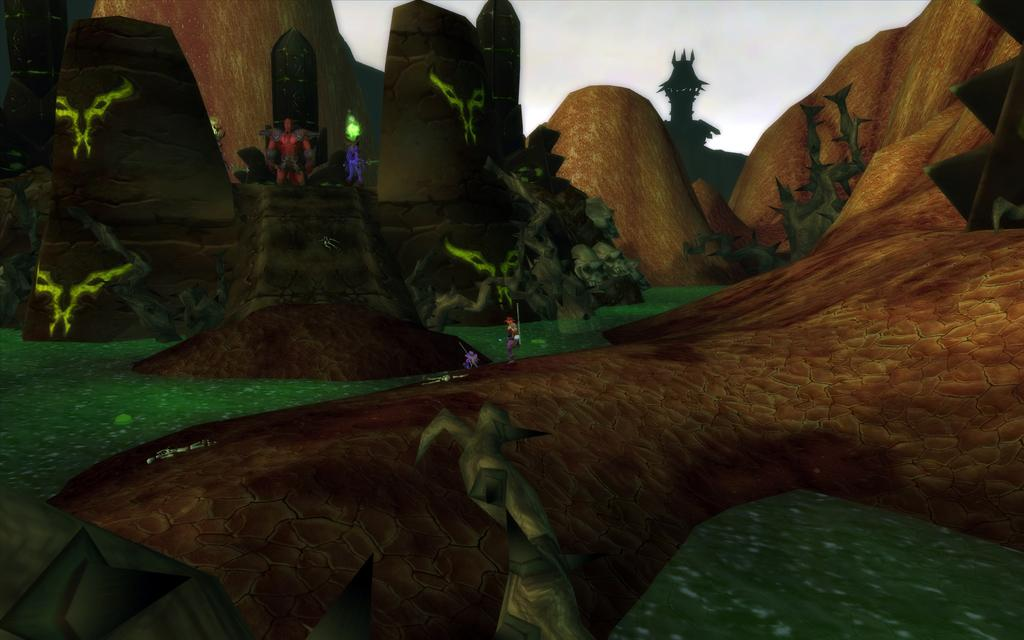What type of image is being described? The image is animated. What geographical features can be seen in the image? There are hills in the image. Who or what is present in the animated image? Animated characters are present in the image. What songs are being sung by the animated characters in the image? There is no information about songs being sung by the animated characters in the image. 